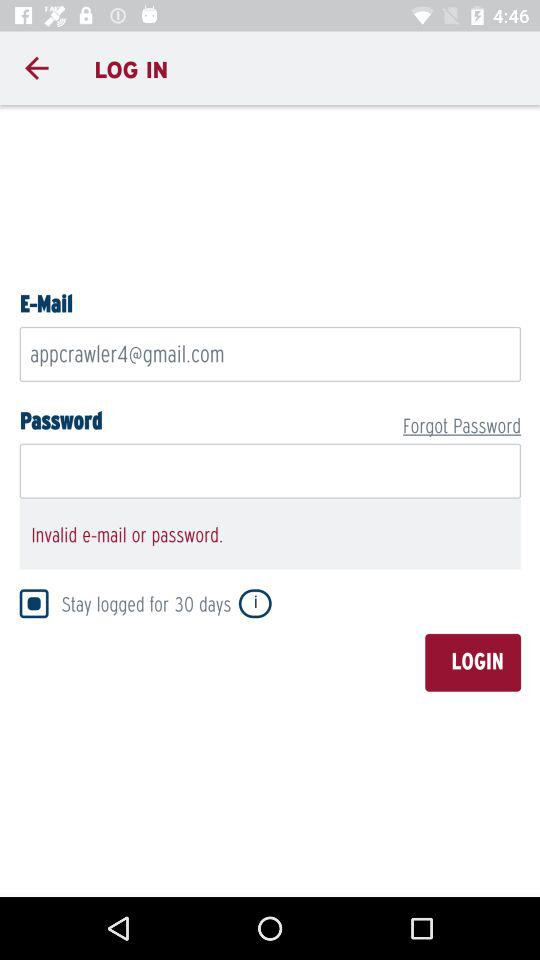What is the status of "Stay logged for 30 days"? The status is "on". 